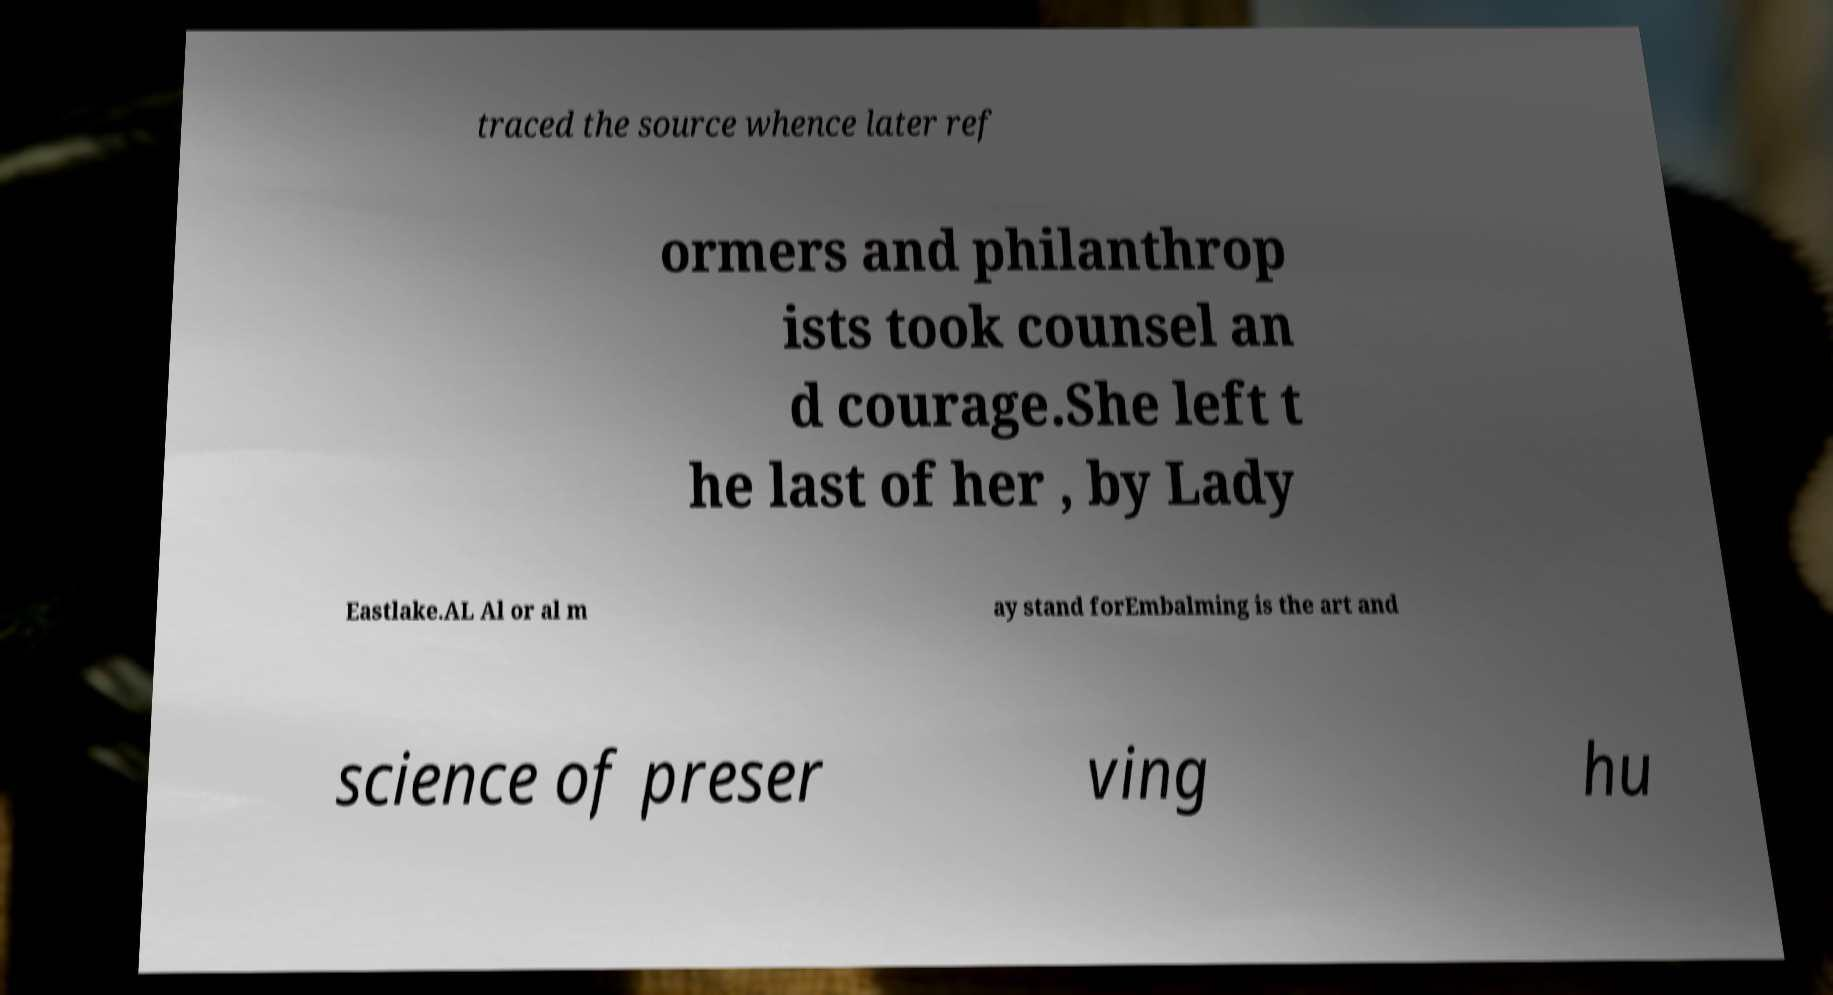Could you assist in decoding the text presented in this image and type it out clearly? traced the source whence later ref ormers and philanthrop ists took counsel an d courage.She left t he last of her , by Lady Eastlake.AL Al or al m ay stand forEmbalming is the art and science of preser ving hu 